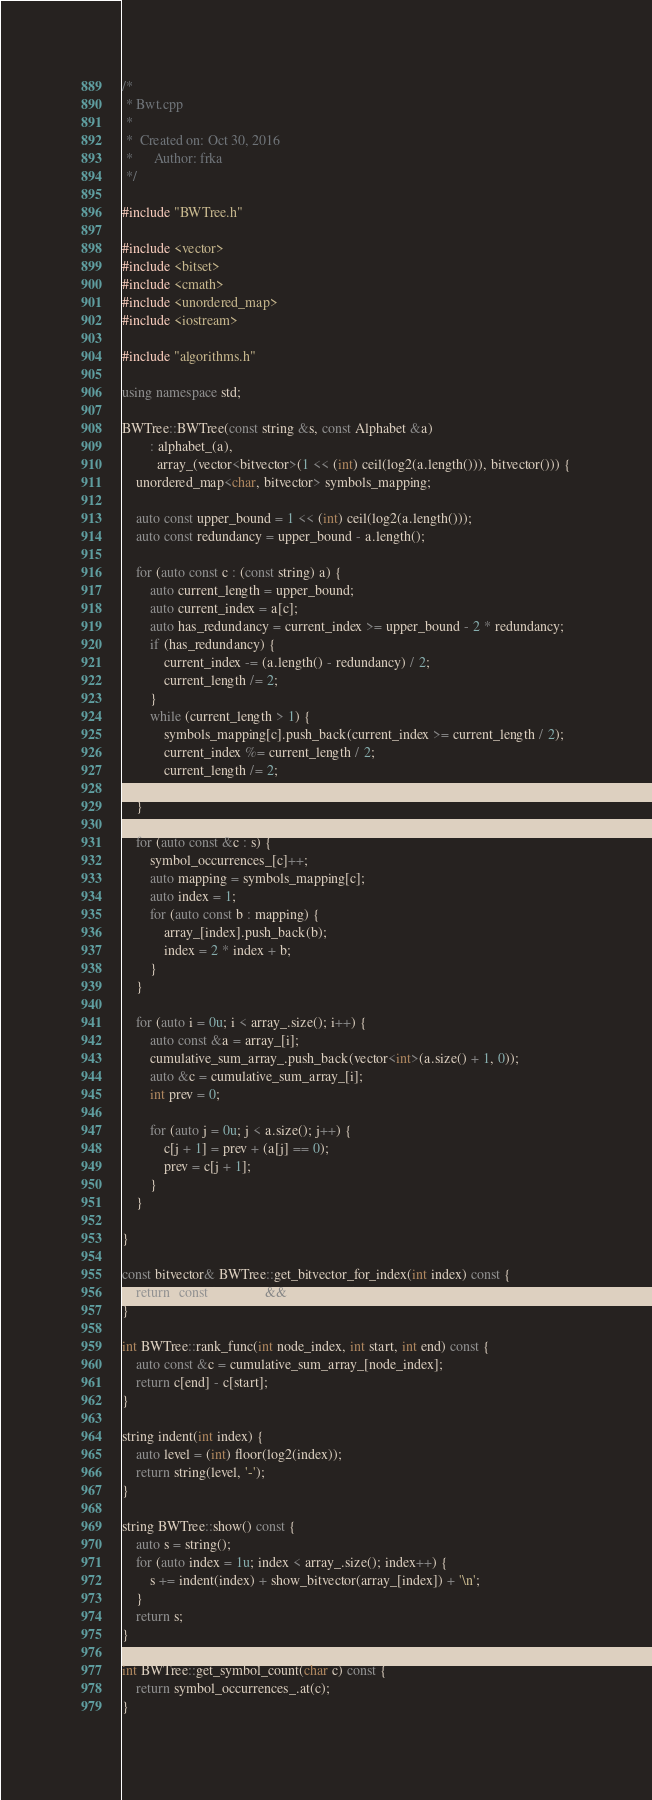Convert code to text. <code><loc_0><loc_0><loc_500><loc_500><_C++_>/*
 * Bwt.cpp
 *
 *  Created on: Oct 30, 2016
 *      Author: frka
 */

#include "BWTree.h"

#include <vector>
#include <bitset>
#include <cmath>
#include <unordered_map>
#include <iostream>

#include "algorithms.h"

using namespace std;

BWTree::BWTree(const string &s, const Alphabet &a)
        : alphabet_(a),
          array_(vector<bitvector>(1 << (int) ceil(log2(a.length())), bitvector())) {
    unordered_map<char, bitvector> symbols_mapping;

    auto const upper_bound = 1 << (int) ceil(log2(a.length()));
    auto const redundancy = upper_bound - a.length();

    for (auto const c : (const string) a) {
        auto current_length = upper_bound;
        auto current_index = a[c];
        auto has_redundancy = current_index >= upper_bound - 2 * redundancy;
        if (has_redundancy) {
            current_index -= (a.length() - redundancy) / 2;
            current_length /= 2;
        }
        while (current_length > 1) {
            symbols_mapping[c].push_back(current_index >= current_length / 2);
            current_index %= current_length / 2;
            current_length /= 2;
        }
    }

    for (auto const &c : s) {
        symbol_occurrences_[c]++;
        auto mapping = symbols_mapping[c];
        auto index = 1;
        for (auto const b : mapping) {
            array_[index].push_back(b);
            index = 2 * index + b;
        }
    }

    for (auto i = 0u; i < array_.size(); i++) {
        auto const &a = array_[i];
        cumulative_sum_array_.push_back(vector<int>(a.size() + 1, 0));
        auto &c = cumulative_sum_array_[i];
        int prev = 0;

        for (auto j = 0u; j < a.size(); j++) {
            c[j + 1] = prev + (a[j] == 0);
            prev = c[j + 1];
        }
    }

}

const bitvector& BWTree::get_bitvector_for_index(int index) const {
    return (const bitvector &&) array_[index];
}

int BWTree::rank_func(int node_index, int start, int end) const {
    auto const &c = cumulative_sum_array_[node_index];
    return c[end] - c[start];
}

string indent(int index) {
    auto level = (int) floor(log2(index));
    return string(level, '-');
}

string BWTree::show() const {
    auto s = string();
    for (auto index = 1u; index < array_.size(); index++) {
        s += indent(index) + show_bitvector(array_[index]) + '\n';
    }
    return s;
}

int BWTree::get_symbol_count(char c) const {
    return symbol_occurrences_.at(c);
}
</code> 